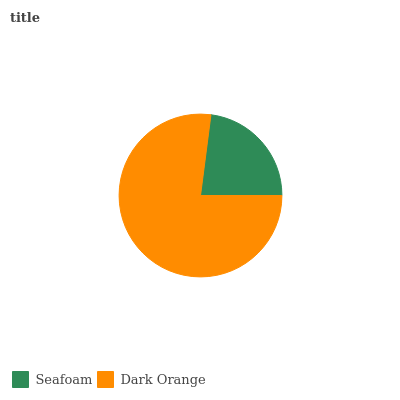Is Seafoam the minimum?
Answer yes or no. Yes. Is Dark Orange the maximum?
Answer yes or no. Yes. Is Dark Orange the minimum?
Answer yes or no. No. Is Dark Orange greater than Seafoam?
Answer yes or no. Yes. Is Seafoam less than Dark Orange?
Answer yes or no. Yes. Is Seafoam greater than Dark Orange?
Answer yes or no. No. Is Dark Orange less than Seafoam?
Answer yes or no. No. Is Dark Orange the high median?
Answer yes or no. Yes. Is Seafoam the low median?
Answer yes or no. Yes. Is Seafoam the high median?
Answer yes or no. No. Is Dark Orange the low median?
Answer yes or no. No. 